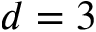<formula> <loc_0><loc_0><loc_500><loc_500>d = 3</formula> 